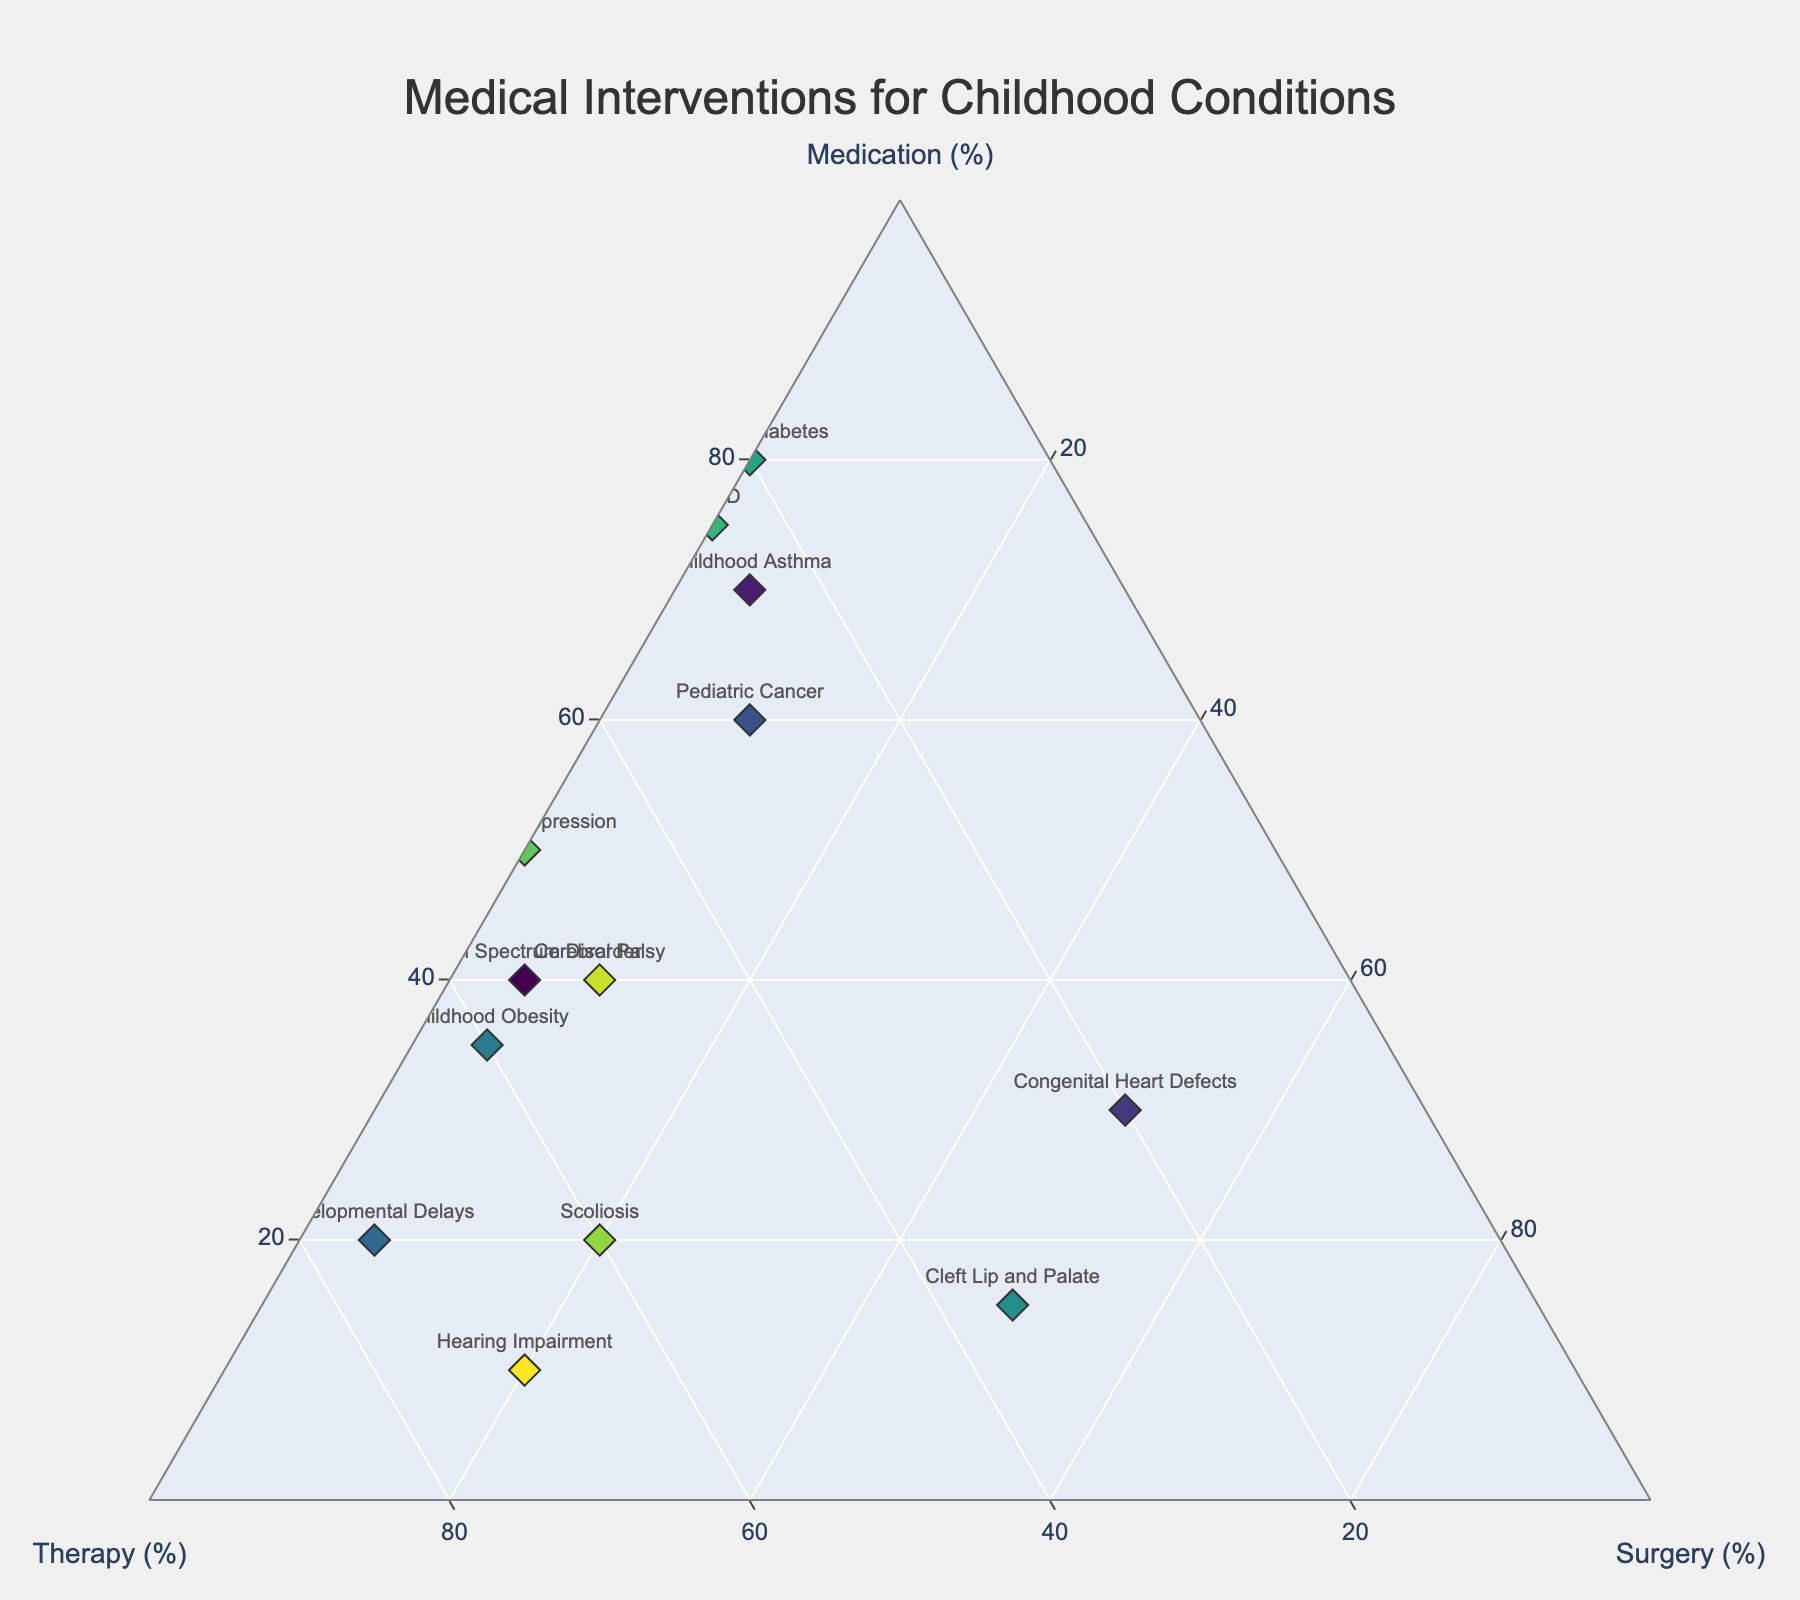How many childhood conditions are shown in the figure? Count the number of unique childhood conditions listed in the Ternary Plot.
Answer: 13 What is the childhood condition with the highest percentage of medication intervention? Locate the condition whose marker is positioned closest to the "Medication" vertex, which is the top vertex of the ternary plot.
Answer: Juvenile Diabetes (80%) Which childhood condition relies the most on therapy intervention? Identify the condition whose marker is positioned closest to the "Therapy" vertex (bottom right of the ternary plot).
Answer: Developmental Delays (75%) For Cleft Lip and Palate, how does the percentage of surgery compare to therapy? Find the position of the Cleft Lip and Palate marker and compare the values on the Surgery and Therapy axes. Surgery is much higher.
Answer: Surgery is higher (50% vs. 35%) Which conditions have no surgical intervention? Identify markers along the edge between the "Medication" and "Therapy" vertices, indicating 0% Surgery.
Answer: Juvenile Diabetes, ADHD, Pediatric Depression What is the most common type of intervention for congenital heart defects? Find the position of the marker for Congenital Heart Defects and observe which vertex it is closest to.
Answer: Surgery (50%) Is the percentage of medical intervention for ADHD more or less than Pediatric Depression? Compare the positions of the ADHD and Pediatric Depression markers along the Medication axis.
Answer: More (75% vs. 50%) Which conditions have an equal percentage of therapy and medication interventions? Look for markers positioned along the axis where Medication and Therapy percentages are equal.
Answer: Pediatric Depression Considering all conditions with less than 20% surgery, which one has the highest therapy percentage? Filter conditions with less than 20% Surgery, then find the one with the highest Therapy value.
Answer: Hearing Impairment (70%) Are there any conditions with a balanced distribution among medication, therapy, and surgery? Check for markers positioned towards the center of the triangle. None of them should be close to balanced.
Answer: No 